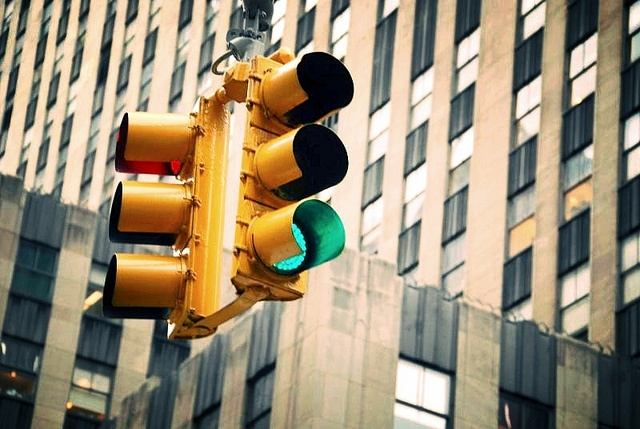Describe the objects in this image and their specific colors. I can see traffic light in gray, orange, brown, black, and maroon tones and traffic light in gray, black, brown, orange, and maroon tones in this image. 